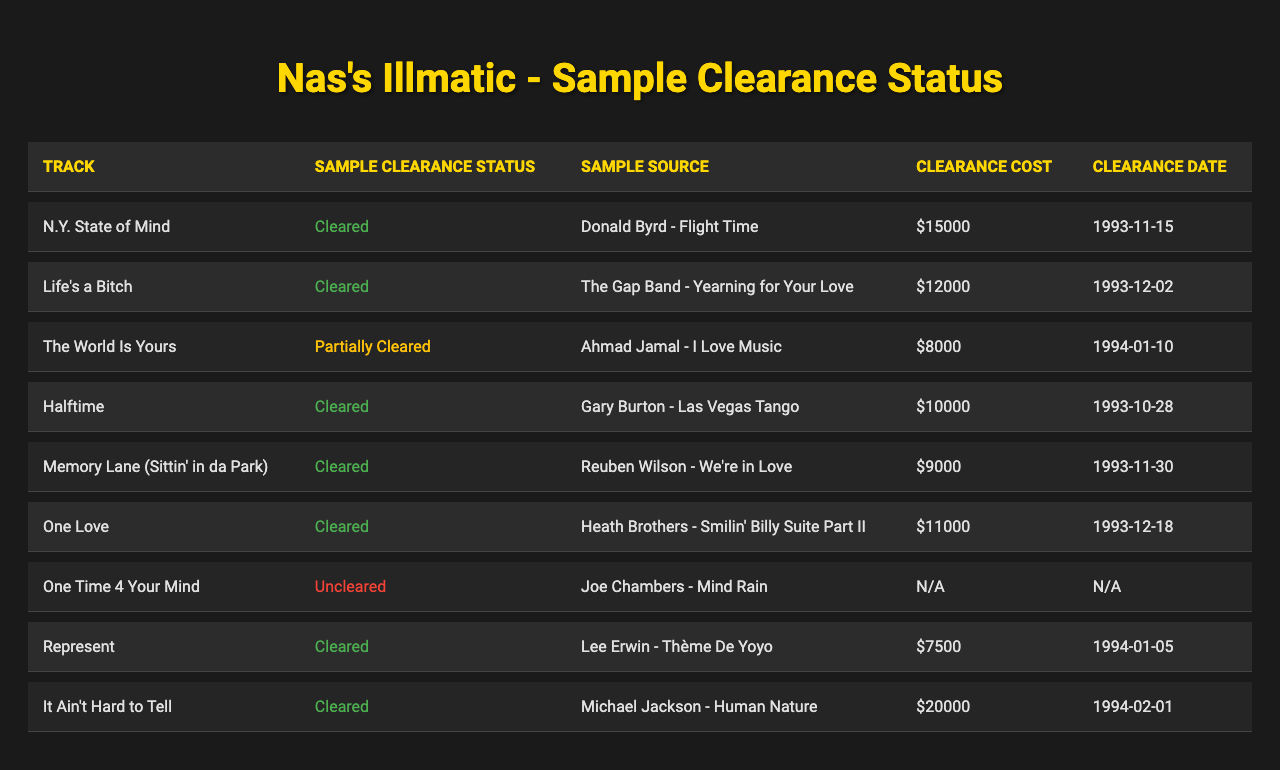What is the sample clearance status of "One Time 4 Your Mind"? The table lists the sample clearance status for each track, and "One Time 4 Your Mind" is marked as "Uncleared."
Answer: Uncleared Which track has a sample source from "Michael Jackson"? By checking the sample sources, "It Ain't Hard to Tell" is associated with "Michael Jackson - Human Nature."
Answer: It Ain't Hard to Tell What is the clearance cost for "Life's a Bitch"? Looking at the clearance costs in the table, "Life's a Bitch" has a clearance cost of $12,000.
Answer: $12,000 Which tracks have been completely cleared? The table shows tracks with their clearance statuses; the ones with the status "Cleared" are "N.Y. State of Mind," "Life's a Bitch," "Halftime," "Memory Lane (Sittin' in da Park)," "One Love," "Represent," and "It Ain't Hard to Tell."
Answer: 7 tracks What is the average clearance cost for the cleared tracks? The cleared tracks and their costs are: $15,000, $12,000, $10,000, $9,000, $11,000, $7,500, and $20,000 which sums up to $84,500. These 7 costs average to $84,500 / 7 = $12,071.43.
Answer: $12,071.43 Is there any track that has an uncleared sample? The table shows that "One Time 4 Your Mind" is marked as "Uncleared," meaning there is at least one track with this status.
Answer: Yes Which track has the earliest clearance date? The earliest date listed is "1993-10-28," which corresponds to "Halftime."
Answer: Halftime What is the difference in clearance cost between the most expensive and least expensive cleared tracks? The most expensive cleared track is "It Ain't Hard to Tell" at $20,000, and the least expensive is "Represent" at $7,500. The difference is $20,000 - $7,500 = $12,500.
Answer: $12,500 How many tracks are listed in total? The table lists a total of 9 tracks under "tracks."
Answer: 9 tracks Are there any sample clearance costs that are not available? Yes, for "One Time 4 Your Mind," the clearance cost is listed as null, indicating it is not available.
Answer: Yes 